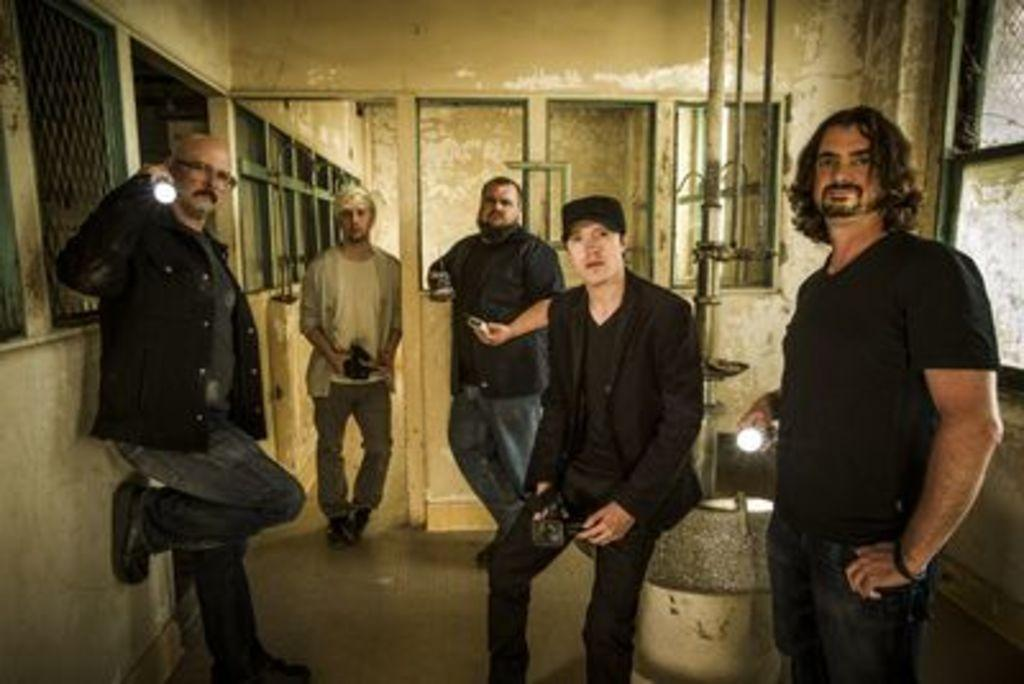What are the people in the image doing with their hands? The people in the image are holding objects. What can be seen through the windows in the image? The facts do not specify what can be seen through the windows. What is the pole in the image used for? The purpose of the pole in the image is not specified. What type of structure is visible in the image? There is a wall in the image, which suggests a building or enclosed space. What type of oranges are being used to decorate the view in the image? There are no oranges or any reference to a view in the image. 